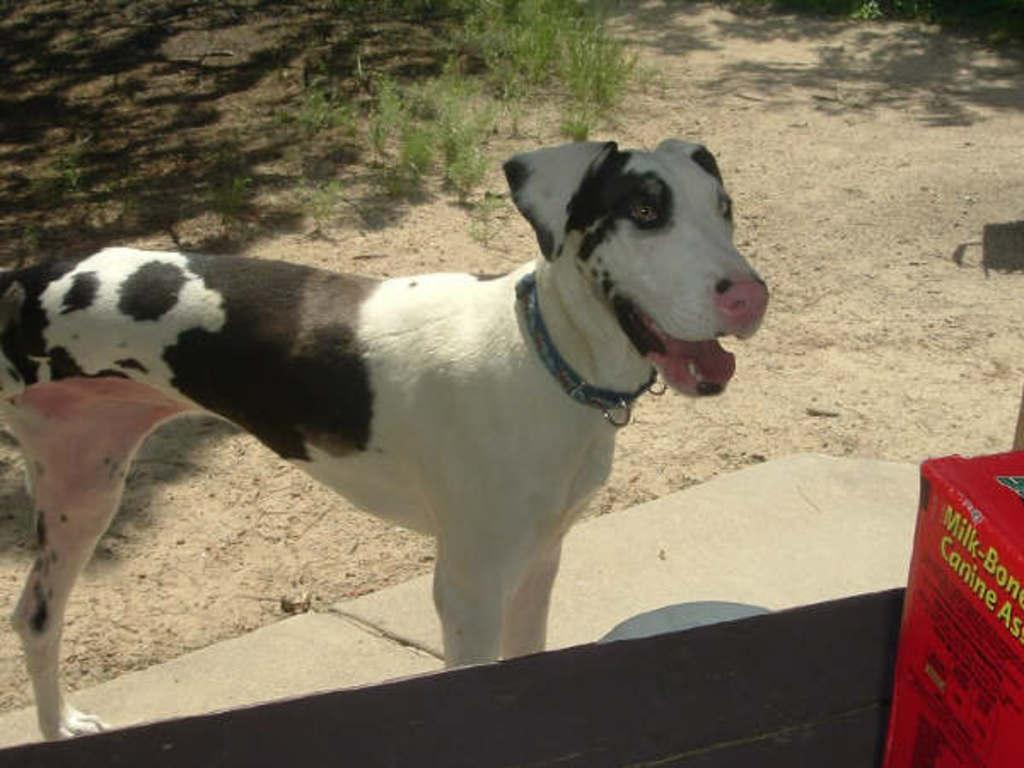What type of animal is in the image? There is a dog in the image. What is the dog wearing? The dog is wearing a collar. What else can be seen in the image besides the dog? There is a box with text in the image. Where is the box located? The box is on a surface. What can be seen in the background of the image? There is grass in the background of the image. What type of joke is written on the calendar in the image? There is no calendar present in the image, so it is not possible to answer that question. 